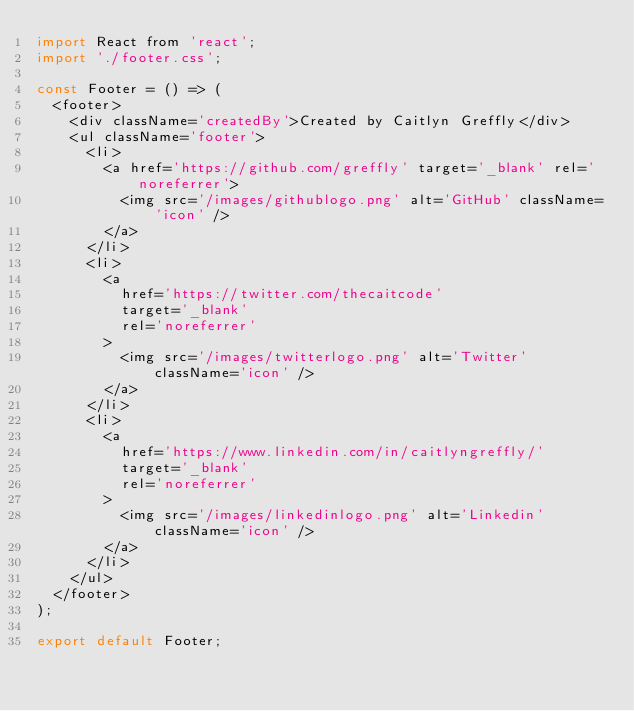<code> <loc_0><loc_0><loc_500><loc_500><_JavaScript_>import React from 'react';
import './footer.css';

const Footer = () => (
  <footer>
    <div className='createdBy'>Created by Caitlyn Greffly</div>
    <ul className='footer'>
      <li>
        <a href='https://github.com/greffly' target='_blank' rel='noreferrer'>
          <img src='/images/githublogo.png' alt='GitHub' className='icon' />
        </a>
      </li>
      <li>
        <a
          href='https://twitter.com/thecaitcode'
          target='_blank'
          rel='noreferrer'
        >
          <img src='/images/twitterlogo.png' alt='Twitter' className='icon' />
        </a>
      </li>
      <li>
        <a
          href='https://www.linkedin.com/in/caitlyngreffly/'
          target='_blank'
          rel='noreferrer'
        >
          <img src='/images/linkedinlogo.png' alt='Linkedin' className='icon' />
        </a>
      </li>
    </ul>
  </footer>
);

export default Footer;
</code> 